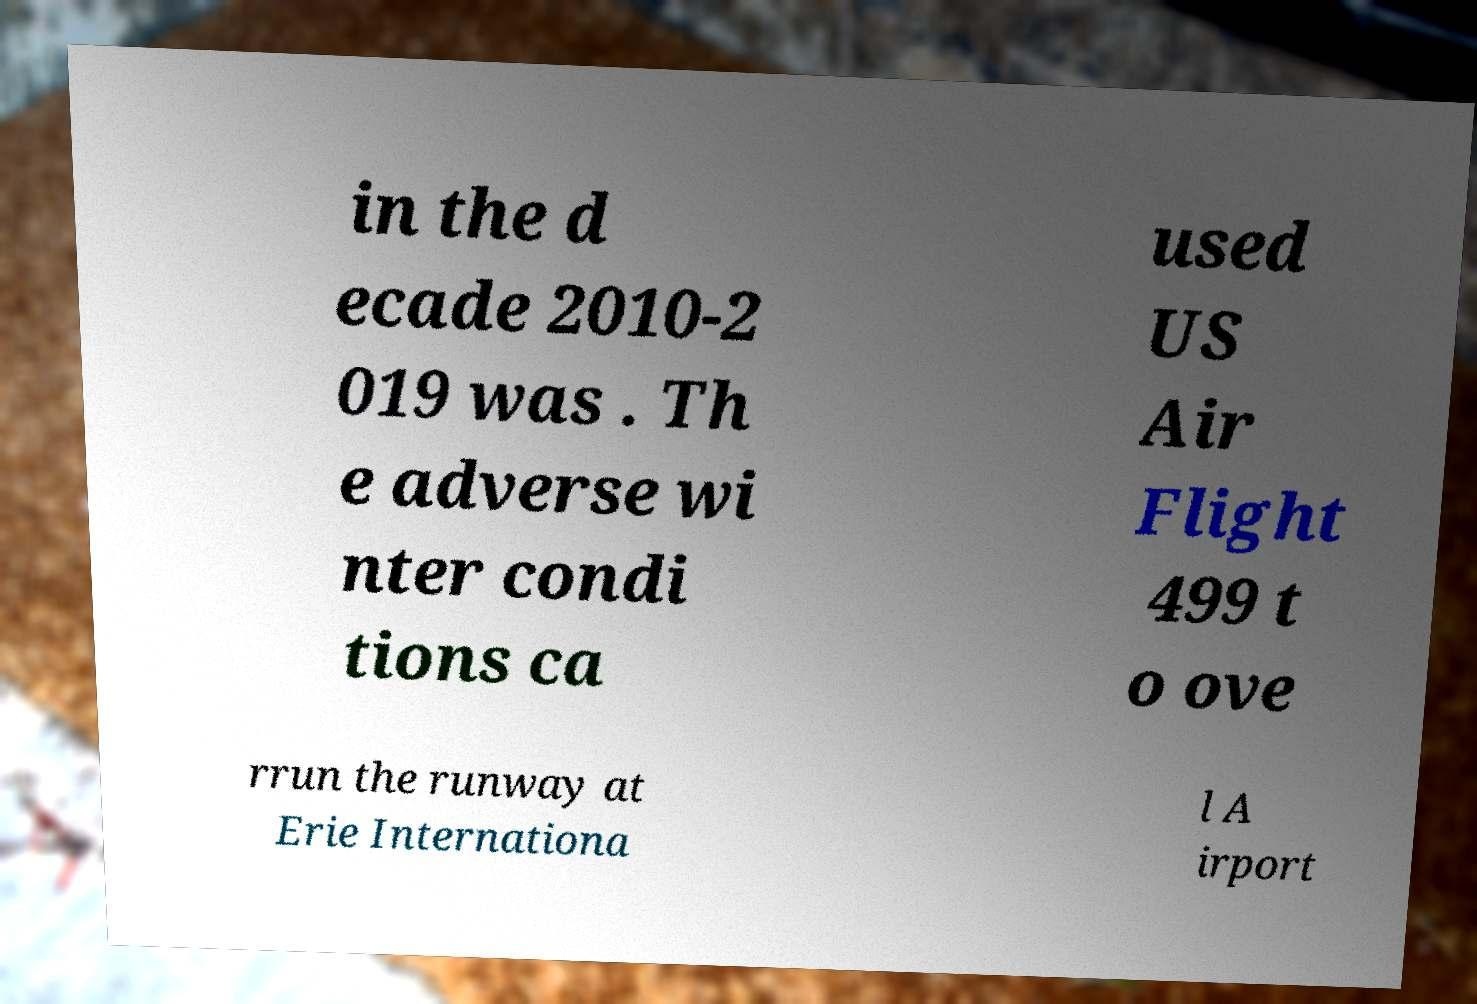What messages or text are displayed in this image? I need them in a readable, typed format. in the d ecade 2010-2 019 was . Th e adverse wi nter condi tions ca used US Air Flight 499 t o ove rrun the runway at Erie Internationa l A irport 